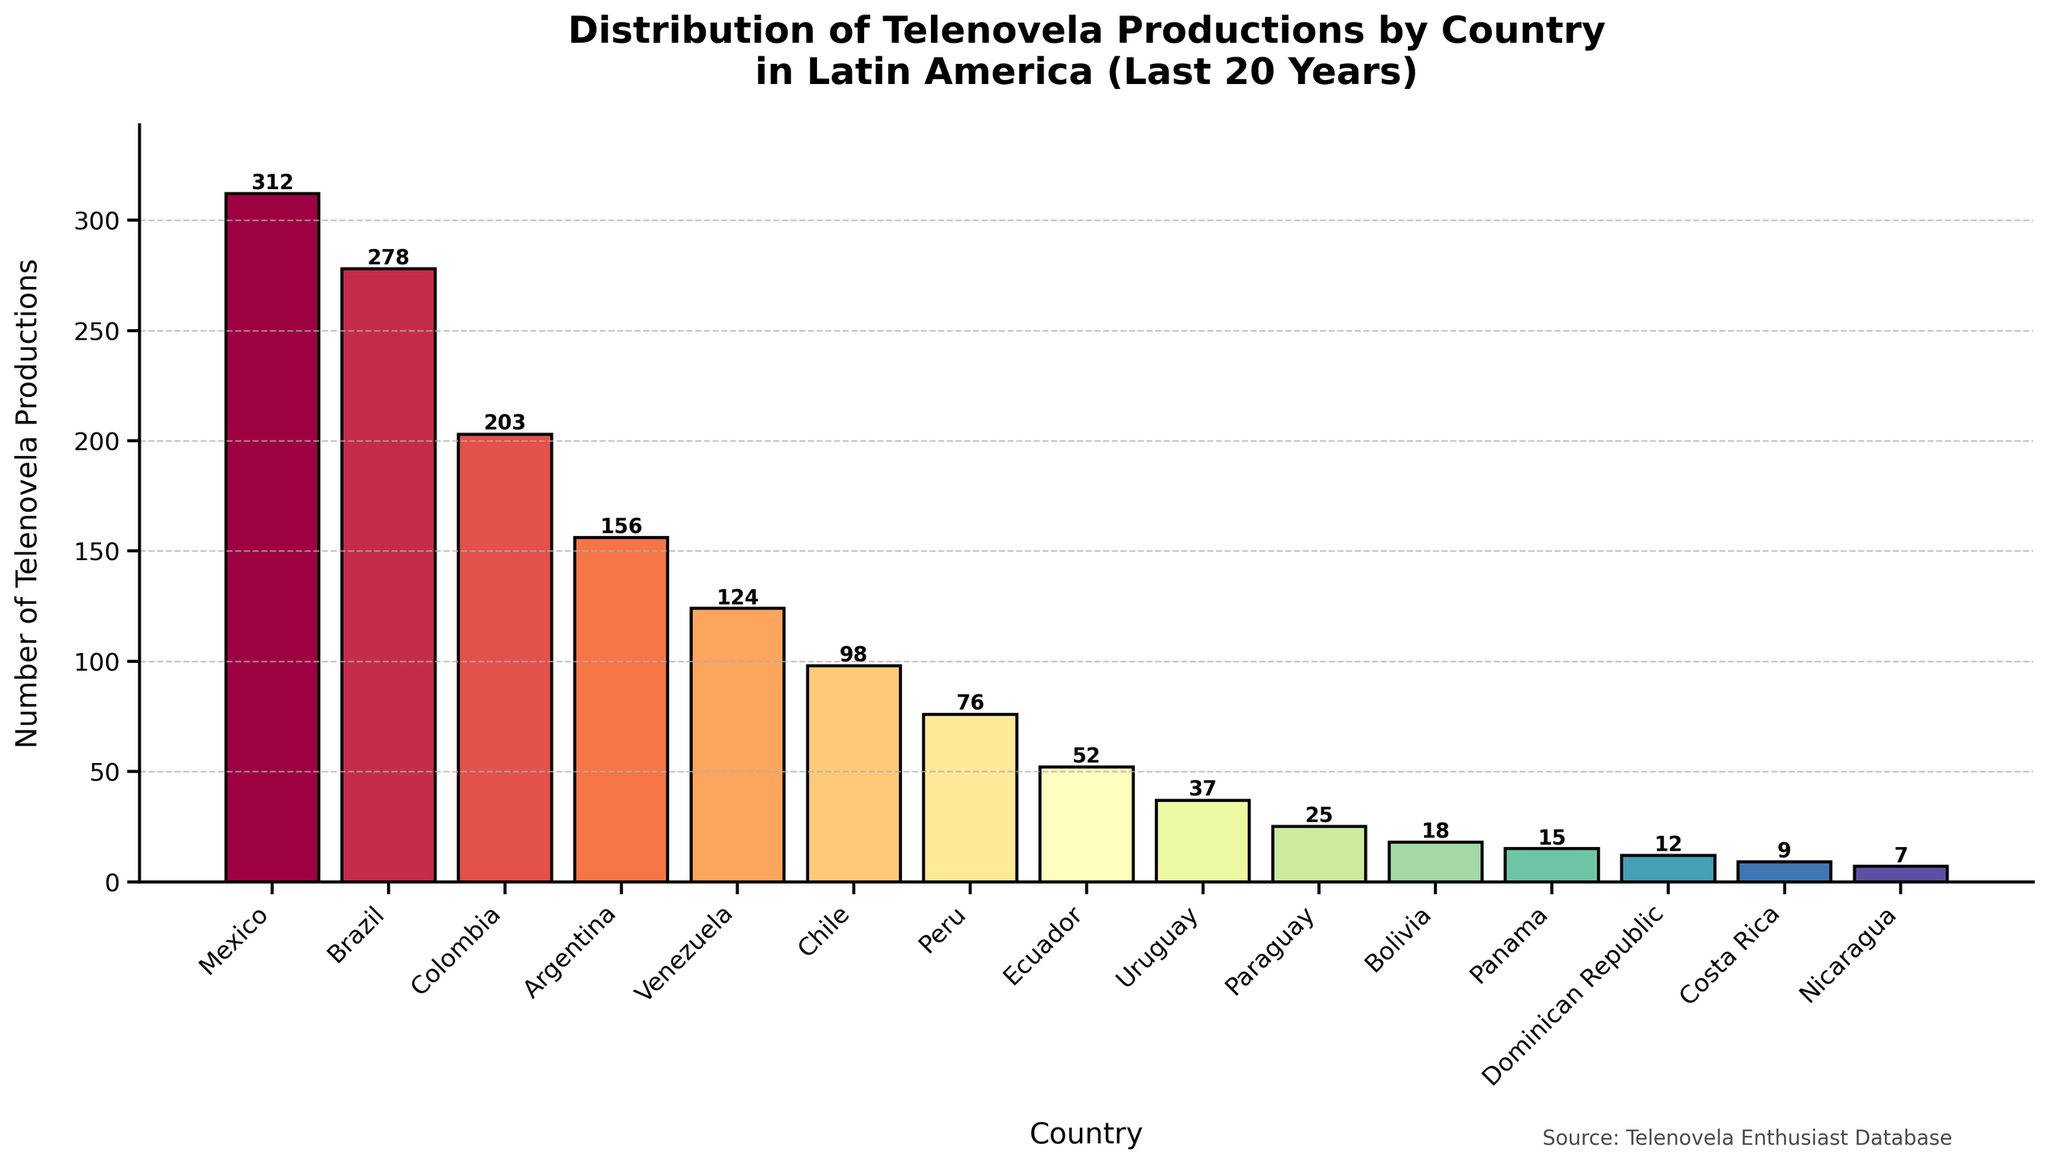Which country has the highest number of telenovela productions? By visually inspecting the heights of the bars, the tallest bar represents Mexico.
Answer: Mexico Which countries have fewer than 20 telenovela productions? By looking at the bars' heights, countries such as Bolivia, Panama, Dominican Republic, Costa Rica, and Nicaragua have bars that represent fewer than 20 productions.
Answer: Bolivia, Panama, Dominican Republic, Costa Rica, Nicaragua What is the total number of telenovela productions in Argentina and Venezuela? Add the number of productions in Argentina (156) and Venezuela (124). 156 + 124 = 280
Answer: 280 Which country has the lowest number of telenovela productions, and how many are there? The shortest bar represents Nicaragua, with 7 productions.
Answer: Nicaragua, 7 How many more telenovela productions does Mexico have compared to Brazil? Subtract the number of productions in Brazil from those in Mexico. 312 - 278 = 34
Answer: 34 What is the average number of telenovela productions for the top 5 countries? Sum the productions of Mexico (312), Brazil (278), Colombia (203), Argentina (156), and Venezuela (124), then divide by 5. (312 + 278 + 203 + 156 + 124) / 5 = 214.6
Answer: 214.6 Which countries have bar colors that are visually distinct compared to others? Mexico's bar is significantly taller and colored differently in the color gradient, whereas countries like Nicaragua have shorter and distinct color bars.
Answer: Mexico, Nicaragua What is the cumulative number of telenovela productions in all countries combined? Sum the number of productions across all countries listed. 312 + 278 + 203 + 156 + 124 + 98 + 76 + 52 + 37 + 25 + 18 + 15 + 12 + 9 + 7 = 1422
Answer: 1422 Which two countries have almost equal numbers of telenovela productions? By comparing the heights of the bars, Ecuador (52) and Uruguay (37) are relatively close but visibly distinct.
Answer: No pairs are visually close enough to be almost equal What percentage of the total productions does Colombia contribute? Calculate the percentage based on Colombia’s productions (203) over the total (1422). (203 / 1422) * 100 = 14.27%
Answer: 14.27% 